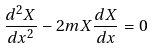<formula> <loc_0><loc_0><loc_500><loc_500>\frac { d ^ { 2 } X } { d x ^ { 2 } } - 2 m X \frac { d X } { d x } = 0</formula> 